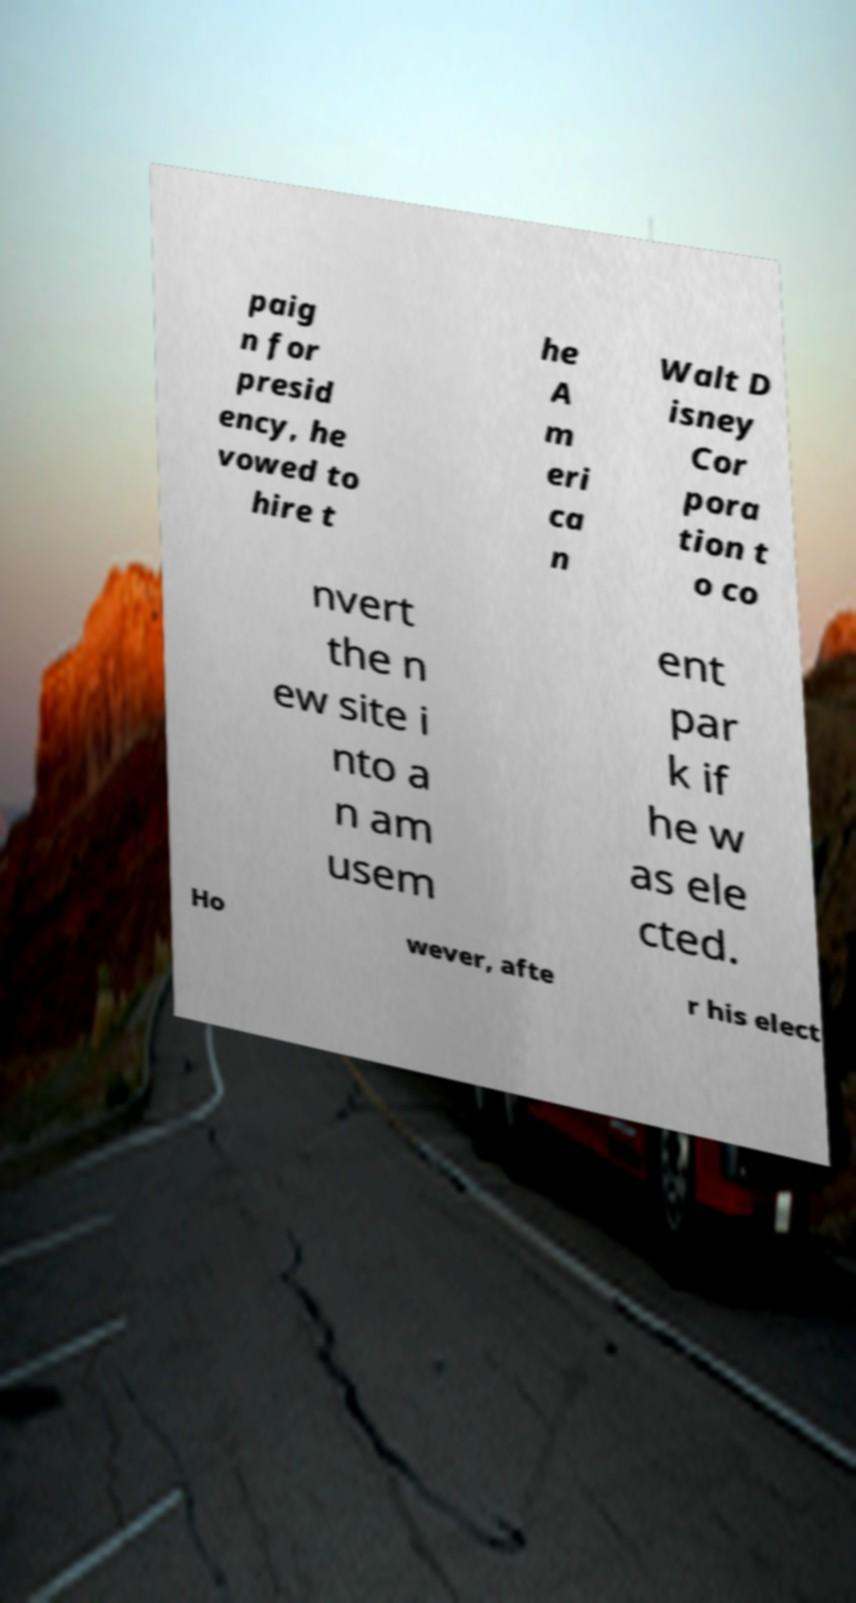Can you accurately transcribe the text from the provided image for me? paig n for presid ency, he vowed to hire t he A m eri ca n Walt D isney Cor pora tion t o co nvert the n ew site i nto a n am usem ent par k if he w as ele cted. Ho wever, afte r his elect 